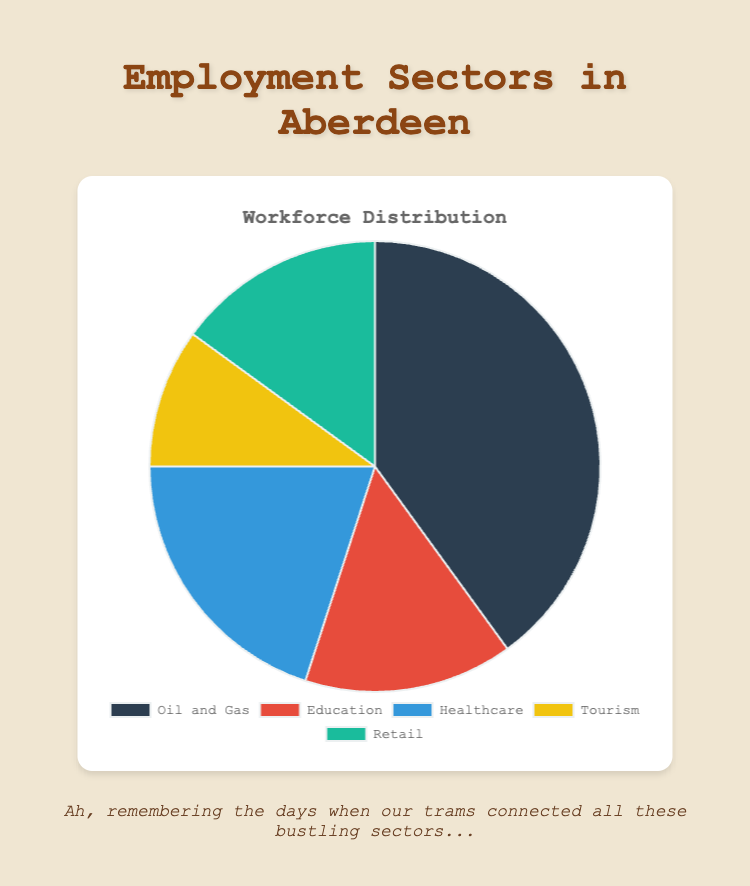Which sector employs the largest percentage of Aberdeen's workforce? The largest segment in the pie chart represents the sector with the greatest percentage. By examining the sizes of all sectors, we see that 'Oil and Gas' has the largest portion.
Answer: Oil and Gas What is the combined percentage of the workforce employed in Education and Retail? The slices of the pie chart corresponding to 'Education' and 'Retail' are 15% each. Adding these together gives 15% + 15% = 30%.
Answer: 30% How much larger is the Oil and Gas sector than the Tourism sector in percentage terms? According to the chart, Oil and Gas is 40% and Tourism is 10%. The difference is 40% - 10% = 30%.
Answer: 30% Which sectors employ an equal percentage of Aberdeen's workforce? By examining the pie chart, we observe that both the 'Education' and 'Retail' sectors have equal slices, each representing 15% of the workforce.
Answer: Education and Retail What is the average percentage of the workforce employed in Healthcare, Tourism, and Retail? Summing up the percentages for Healthcare (20%), Tourism (10%), and Retail (15%) gives 20% + 10% + 15% = 45%. Since there are three sectors, we divide the total by 3. Thus, the average is 45% / 3 = 15%.
Answer: 15% Which sector is represented by the yellow slice in the pie chart? The pie chart’s legend will show that the yellow slice corresponds to Tourism.
Answer: Tourism If the Oil and Gas sector were to decrease to 30%, what would be the new total percentage if Education and Healthcare increased by 5% each? Currently, Oil and Gas is 40%. A decrease to 30% means a difference of 10%. Increasing Education and Healthcare by 5% each results in new percentages of 20% + 25% respectively. The new total is 30% + 20% + 25% + 10%(Tourism) + 15%(Retail) = 100%.
Answer: 100% Which sector employs twice as many people as Tourism? Examining the chart, we see that Healthcare employs 20%, which is twice the percentage of Tourism at 10%.
Answer: Healthcare 